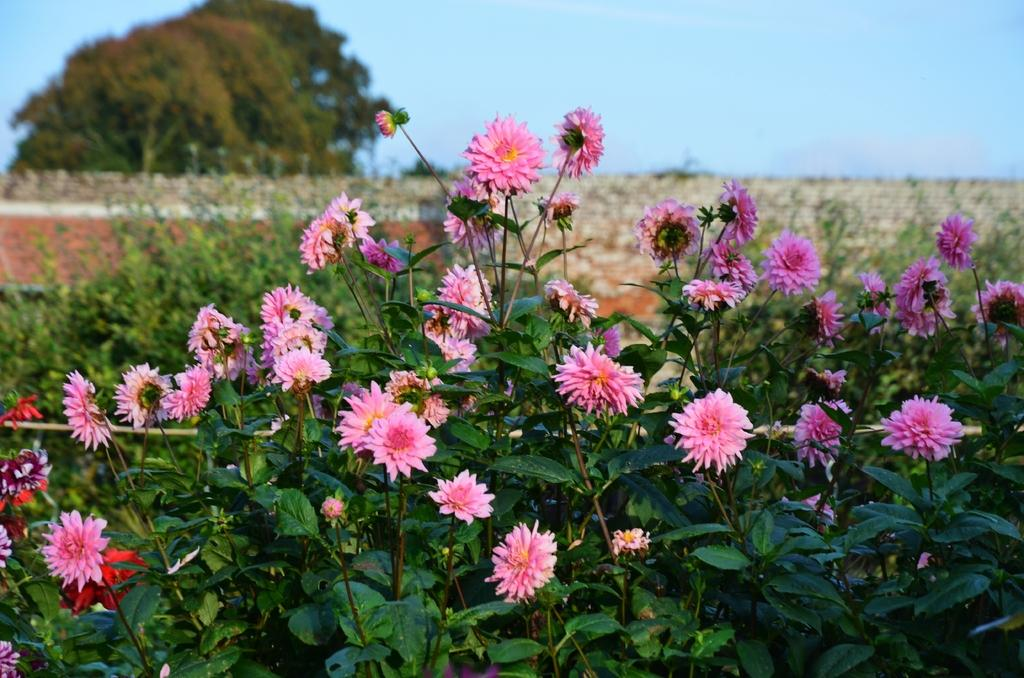What types of plants can be seen in the image? There are plants with flowers, leaves, and buds in the image. Are there any other plants visible in the image? Yes, there are additional plants behind the first set of plants. What can be seen in the left top part of the image? There are trees visible in the left top part of the image. What is visible at the top of the image? The sky is visible at the top of the image. How many brothers are visible in the image? There are no brothers present in the image; it features plants and trees. What type of brake can be seen on the plants in the image? There is no brake present on the plants in the image; they are natural plants with no mechanical components. 